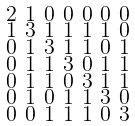Convert formula to latex. <formula><loc_0><loc_0><loc_500><loc_500>\begin{smallmatrix} 2 & 1 & 0 & 0 & 0 & 0 & 0 \\ 1 & 3 & 1 & 1 & 1 & 1 & 0 \\ 0 & 1 & 3 & 1 & 1 & 0 & 1 \\ 0 & 1 & 1 & 3 & 0 & 1 & 1 \\ 0 & 1 & 1 & 0 & 3 & 1 & 1 \\ 0 & 1 & 0 & 1 & 1 & 3 & 0 \\ 0 & 0 & 1 & 1 & 1 & 0 & 3 \end{smallmatrix}</formula> 